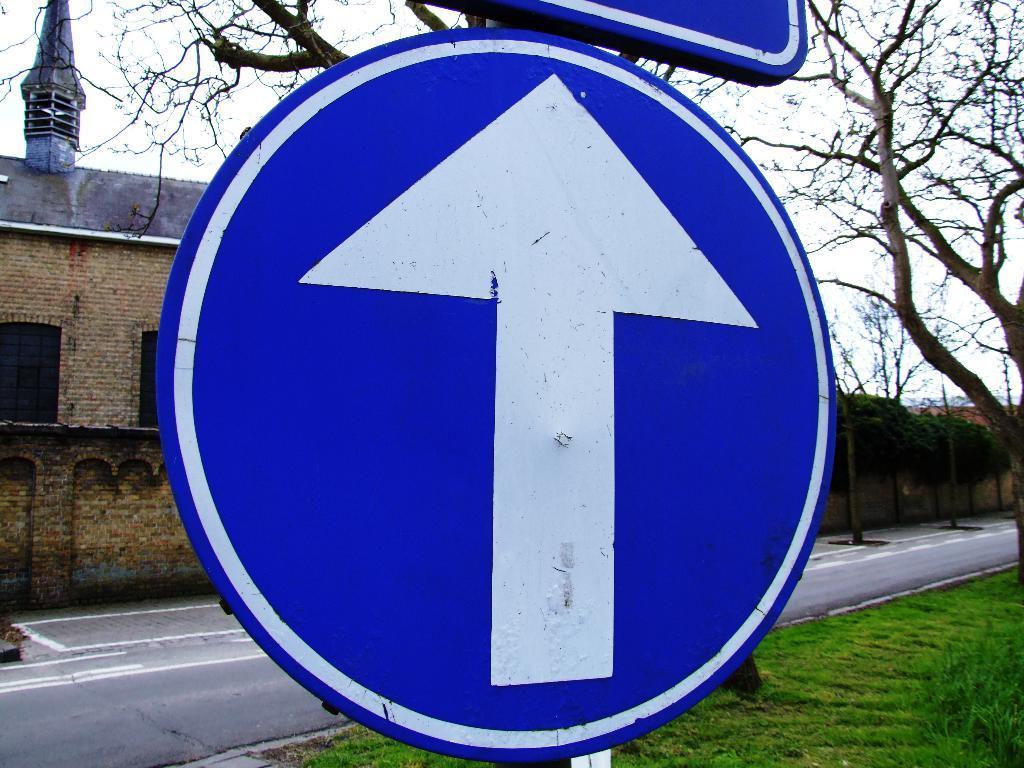Describe this image in one or two sentences. In this picture there is a sign on the board and there are boards on the pole. At the back there is a building and there are trees. At the top there is sky. At the bottom there is a road and there is grass. 